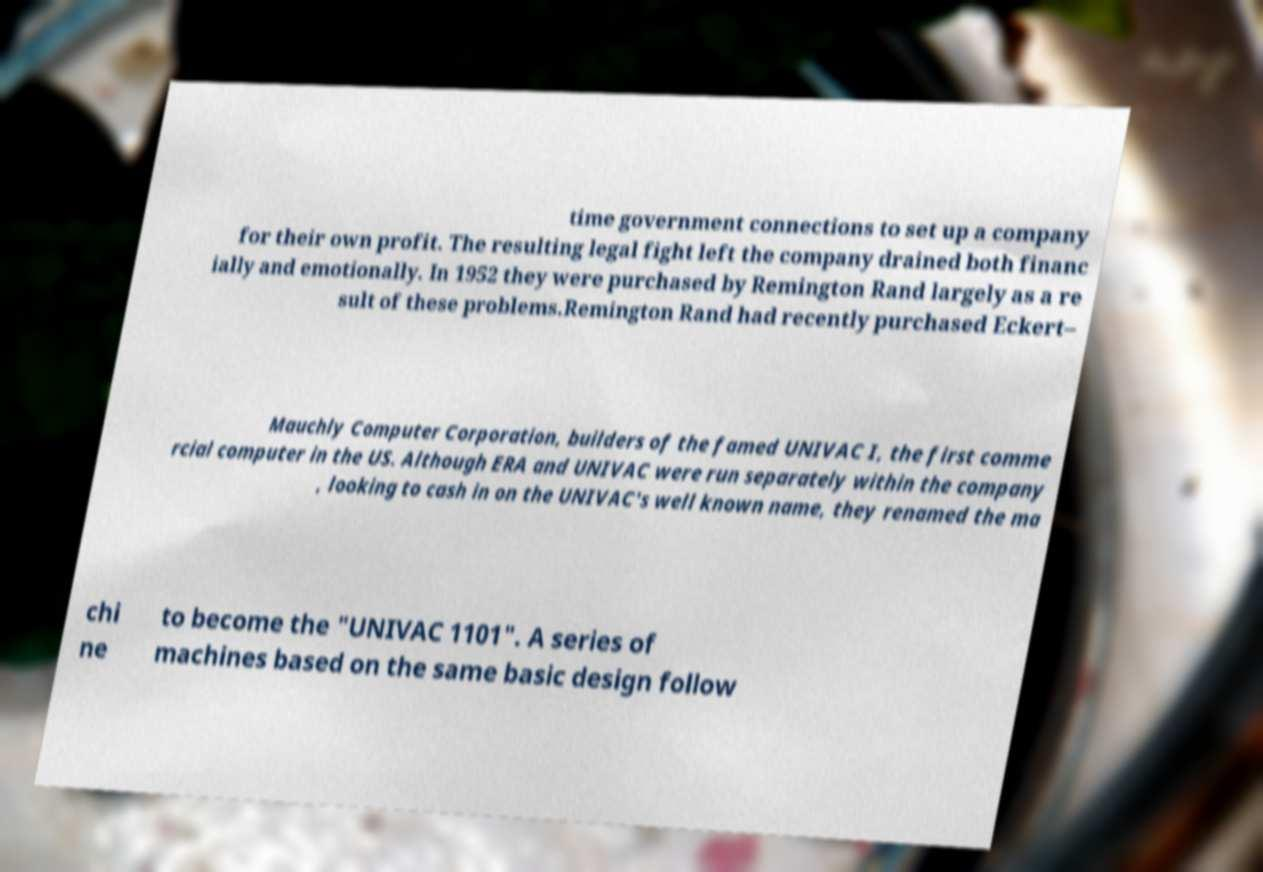Please read and relay the text visible in this image. What does it say? time government connections to set up a company for their own profit. The resulting legal fight left the company drained both financ ially and emotionally. In 1952 they were purchased by Remington Rand largely as a re sult of these problems.Remington Rand had recently purchased Eckert– Mauchly Computer Corporation, builders of the famed UNIVAC I, the first comme rcial computer in the US. Although ERA and UNIVAC were run separately within the company , looking to cash in on the UNIVAC's well known name, they renamed the ma chi ne to become the "UNIVAC 1101". A series of machines based on the same basic design follow 